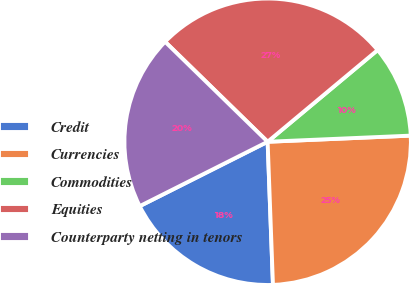<chart> <loc_0><loc_0><loc_500><loc_500><pie_chart><fcel>Credit<fcel>Currencies<fcel>Commodities<fcel>Equities<fcel>Counterparty netting in tenors<nl><fcel>18.17%<fcel>25.09%<fcel>10.38%<fcel>26.64%<fcel>19.72%<nl></chart> 